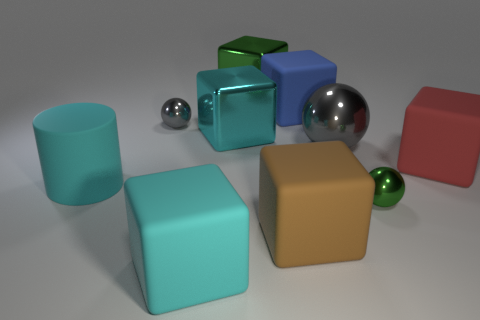Subtract 2 cubes. How many cubes are left? 4 Subtract all cyan blocks. How many blocks are left? 4 Subtract all cyan metallic blocks. How many blocks are left? 5 Subtract all purple blocks. Subtract all yellow cylinders. How many blocks are left? 6 Subtract all cylinders. How many objects are left? 9 Subtract 0 yellow balls. How many objects are left? 10 Subtract all big cyan matte blocks. Subtract all tiny green shiny balls. How many objects are left? 8 Add 5 big red cubes. How many big red cubes are left? 6 Add 6 tiny metal cylinders. How many tiny metal cylinders exist? 6 